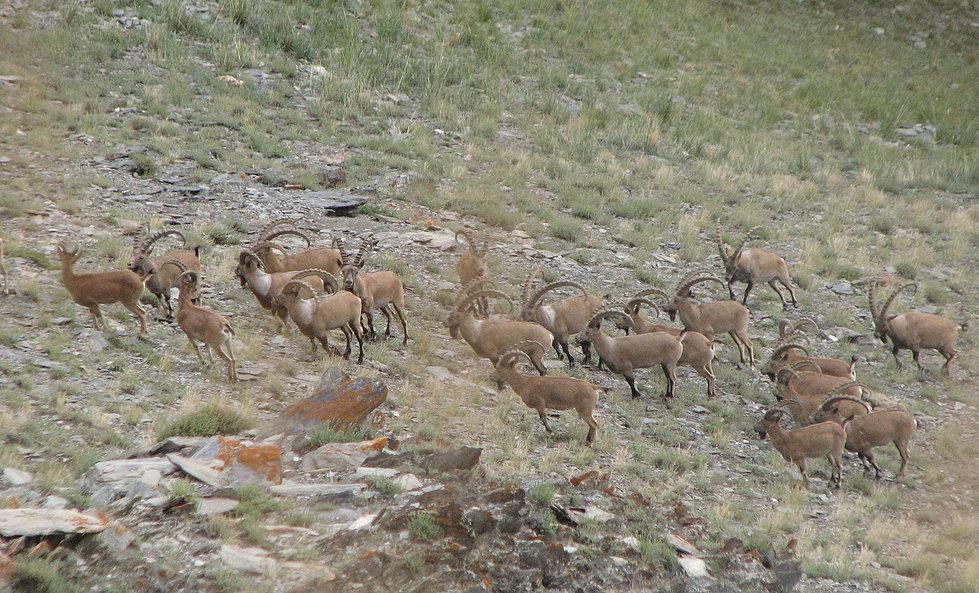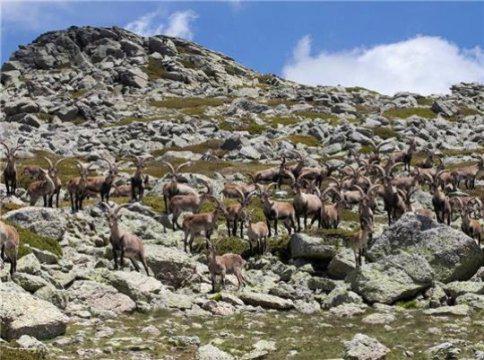The first image is the image on the left, the second image is the image on the right. Analyze the images presented: Is the assertion "No image contains more than three hooved animals." valid? Answer yes or no. No. 